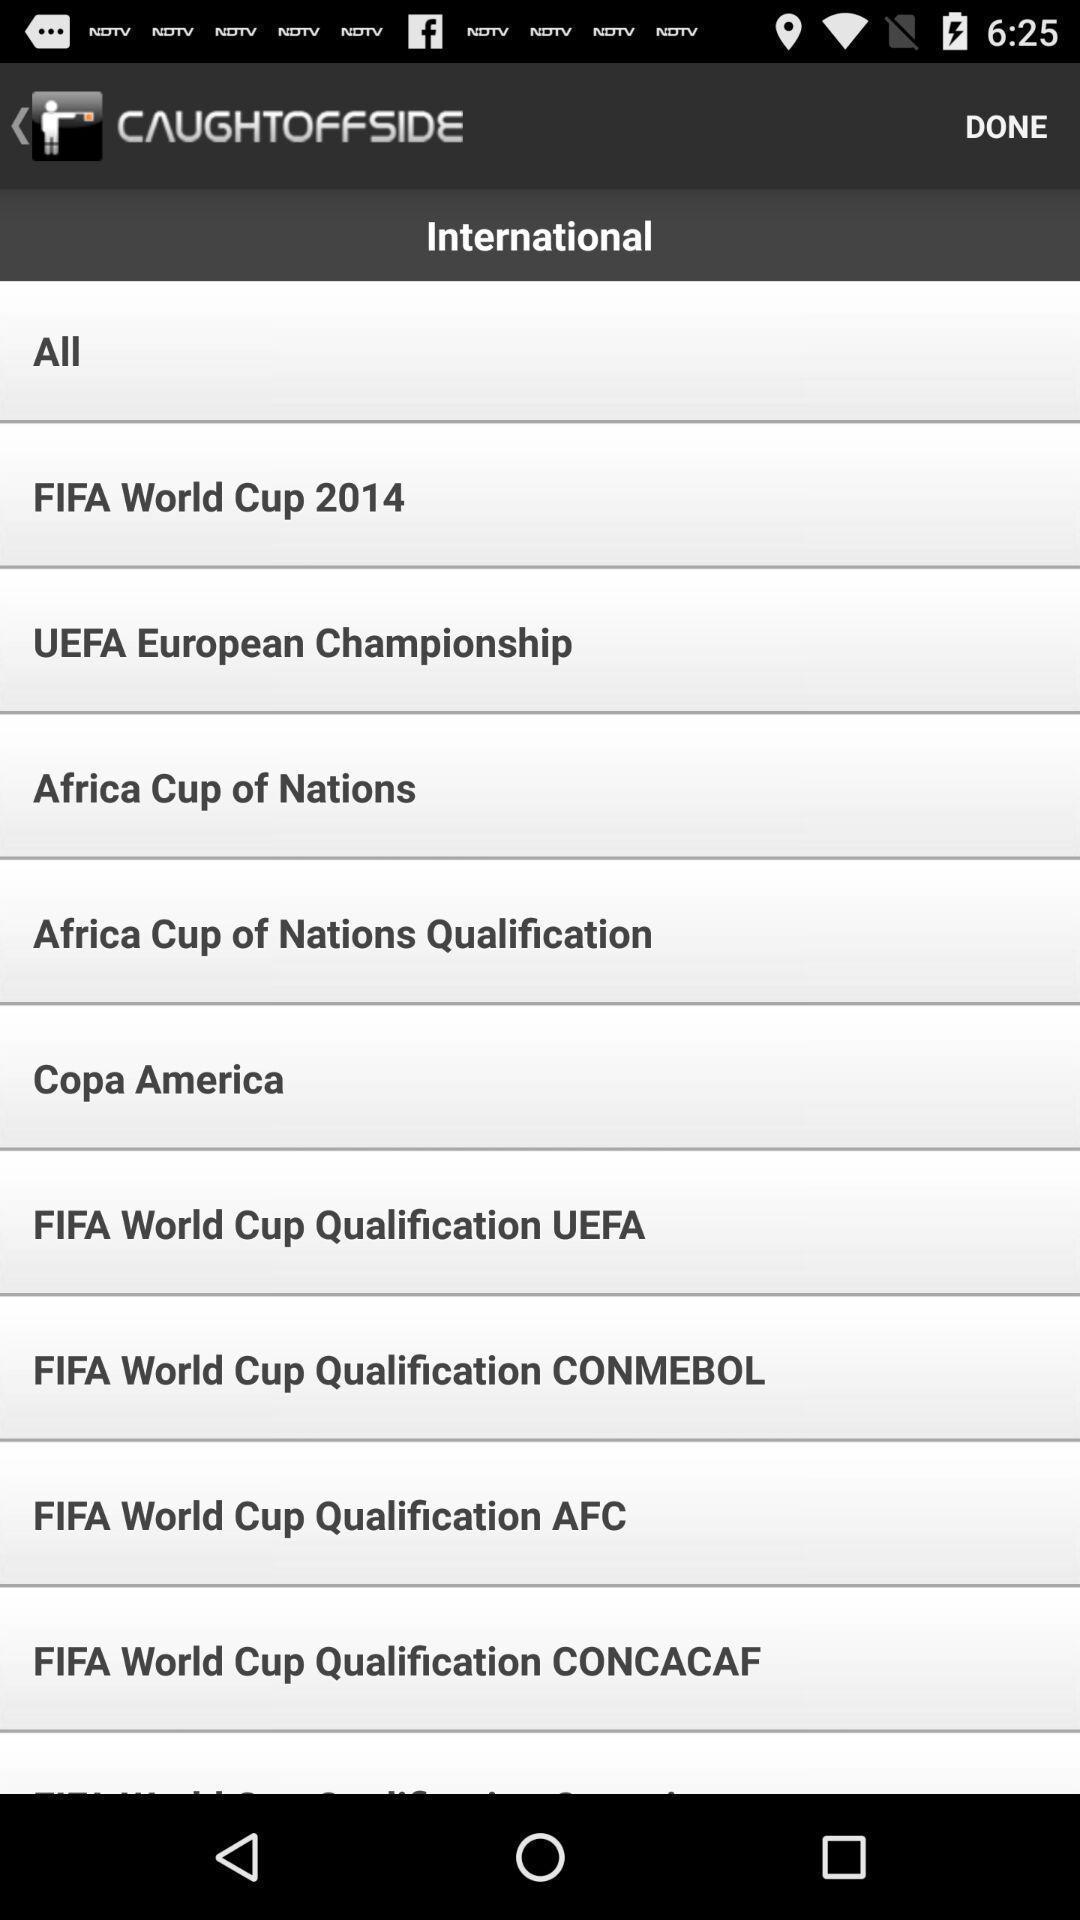Explain the elements present in this screenshot. Screen with world cup championship in an sports application. 